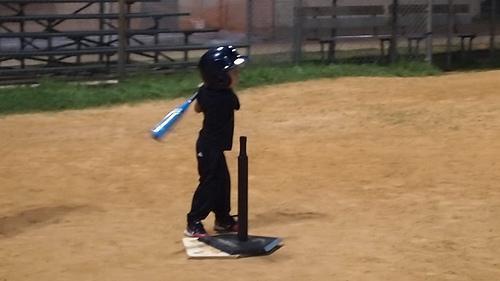How many boys are there?
Give a very brief answer. 1. 